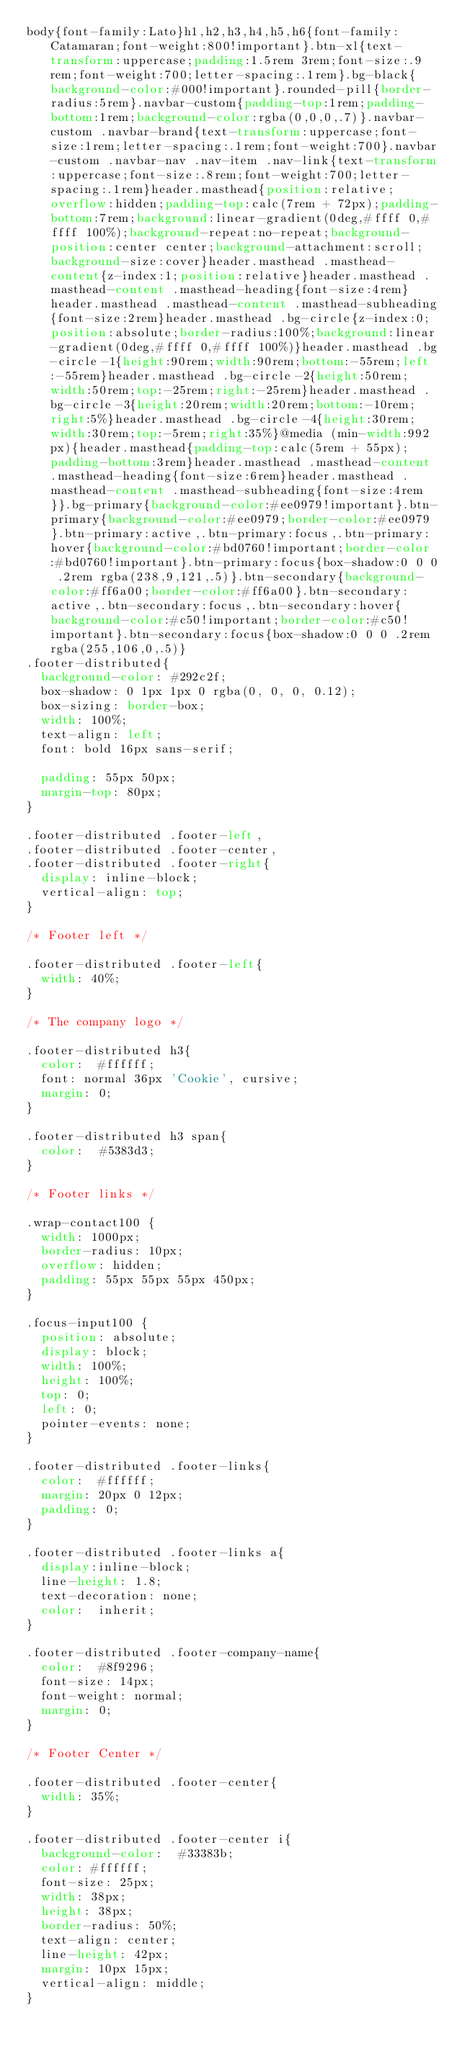Convert code to text. <code><loc_0><loc_0><loc_500><loc_500><_CSS_>body{font-family:Lato}h1,h2,h3,h4,h5,h6{font-family:Catamaran;font-weight:800!important}.btn-xl{text-transform:uppercase;padding:1.5rem 3rem;font-size:.9rem;font-weight:700;letter-spacing:.1rem}.bg-black{background-color:#000!important}.rounded-pill{border-radius:5rem}.navbar-custom{padding-top:1rem;padding-bottom:1rem;background-color:rgba(0,0,0,.7)}.navbar-custom .navbar-brand{text-transform:uppercase;font-size:1rem;letter-spacing:.1rem;font-weight:700}.navbar-custom .navbar-nav .nav-item .nav-link{text-transform:uppercase;font-size:.8rem;font-weight:700;letter-spacing:.1rem}header.masthead{position:relative;overflow:hidden;padding-top:calc(7rem + 72px);padding-bottom:7rem;background:linear-gradient(0deg,#ffff 0,#ffff 100%);background-repeat:no-repeat;background-position:center center;background-attachment:scroll;background-size:cover}header.masthead .masthead-content{z-index:1;position:relative}header.masthead .masthead-content .masthead-heading{font-size:4rem}header.masthead .masthead-content .masthead-subheading{font-size:2rem}header.masthead .bg-circle{z-index:0;position:absolute;border-radius:100%;background:linear-gradient(0deg,#ffff 0,#ffff 100%)}header.masthead .bg-circle-1{height:90rem;width:90rem;bottom:-55rem;left:-55rem}header.masthead .bg-circle-2{height:50rem;width:50rem;top:-25rem;right:-25rem}header.masthead .bg-circle-3{height:20rem;width:20rem;bottom:-10rem;right:5%}header.masthead .bg-circle-4{height:30rem;width:30rem;top:-5rem;right:35%}@media (min-width:992px){header.masthead{padding-top:calc(5rem + 55px);padding-bottom:3rem}header.masthead .masthead-content .masthead-heading{font-size:6rem}header.masthead .masthead-content .masthead-subheading{font-size:4rem}}.bg-primary{background-color:#ee0979!important}.btn-primary{background-color:#ee0979;border-color:#ee0979}.btn-primary:active,.btn-primary:focus,.btn-primary:hover{background-color:#bd0760!important;border-color:#bd0760!important}.btn-primary:focus{box-shadow:0 0 0 .2rem rgba(238,9,121,.5)}.btn-secondary{background-color:#ff6a00;border-color:#ff6a00}.btn-secondary:active,.btn-secondary:focus,.btn-secondary:hover{background-color:#c50!important;border-color:#c50!important}.btn-secondary:focus{box-shadow:0 0 0 .2rem rgba(255,106,0,.5)}
.footer-distributed{
	background-color: #292c2f;
	box-shadow: 0 1px 1px 0 rgba(0, 0, 0, 0.12);
	box-sizing: border-box;
	width: 100%;
	text-align: left;
	font: bold 16px sans-serif;

	padding: 55px 50px;
	margin-top: 80px;
}

.footer-distributed .footer-left,
.footer-distributed .footer-center,
.footer-distributed .footer-right{
	display: inline-block;
	vertical-align: top;
}

/* Footer left */

.footer-distributed .footer-left{
	width: 40%;
}

/* The company logo */

.footer-distributed h3{
	color:  #ffffff;
	font: normal 36px 'Cookie', cursive;
	margin: 0;
}

.footer-distributed h3 span{
	color:  #5383d3;
}

/* Footer links */

.wrap-contact100 {
  width: 1000px;
  border-radius: 10px;
  overflow: hidden;
  padding: 55px 55px 55px 450px;
}

.focus-input100 {
  position: absolute;
  display: block;
  width: 100%;
  height: 100%;
  top: 0;
  left: 0;
  pointer-events: none;
}

.footer-distributed .footer-links{
	color:  #ffffff;
	margin: 20px 0 12px;
	padding: 0;
}

.footer-distributed .footer-links a{
	display:inline-block;
	line-height: 1.8;
	text-decoration: none;
	color:  inherit;
}

.footer-distributed .footer-company-name{
	color:  #8f9296;
	font-size: 14px;
	font-weight: normal;
	margin: 0;
}

/* Footer Center */

.footer-distributed .footer-center{
	width: 35%;
}

.footer-distributed .footer-center i{
	background-color:  #33383b;
	color: #ffffff;
	font-size: 25px;
	width: 38px;
	height: 38px;
	border-radius: 50%;
	text-align: center;
	line-height: 42px;
	margin: 10px 15px;
	vertical-align: middle;
}
</code> 